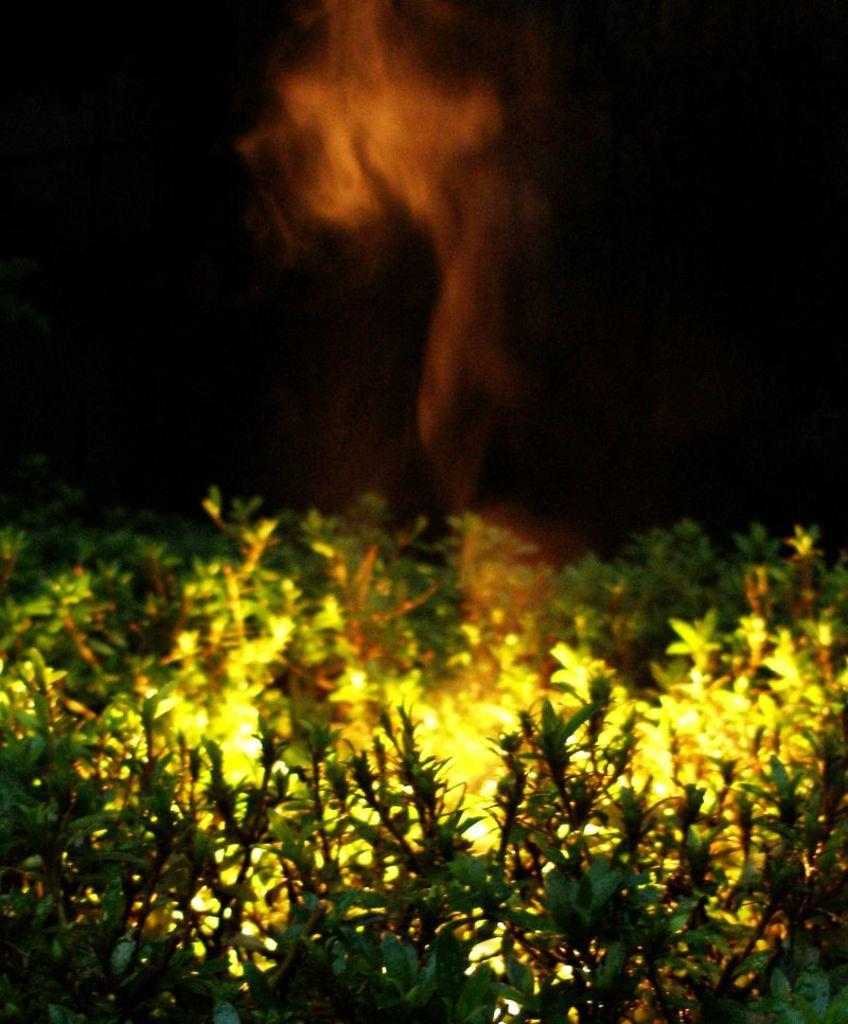What is located at the bottom of the image? There are plants at the bottom of the image. What is present between the plants? There are lights between the plants. What can be seen at the top of the image? There is smoke at the top of the image. How would you describe the overall lighting in the image? The background of the image is dark, but there are lights between the plants. What achievement is the moon celebrating in the image? There is no moon present in the image, and therefore no achievement to celebrate. 